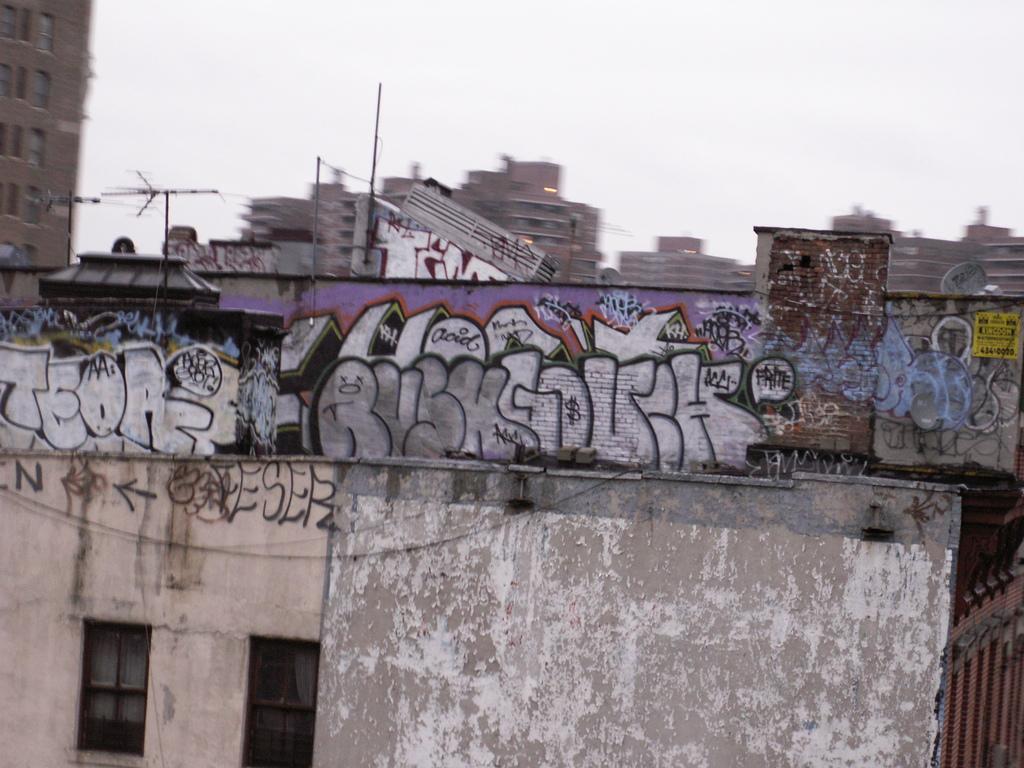How would you summarize this image in a sentence or two? In this image there are buildings, roads and cloudy sky. Graffiti is on the wall. In the background of the image it is blurry. 